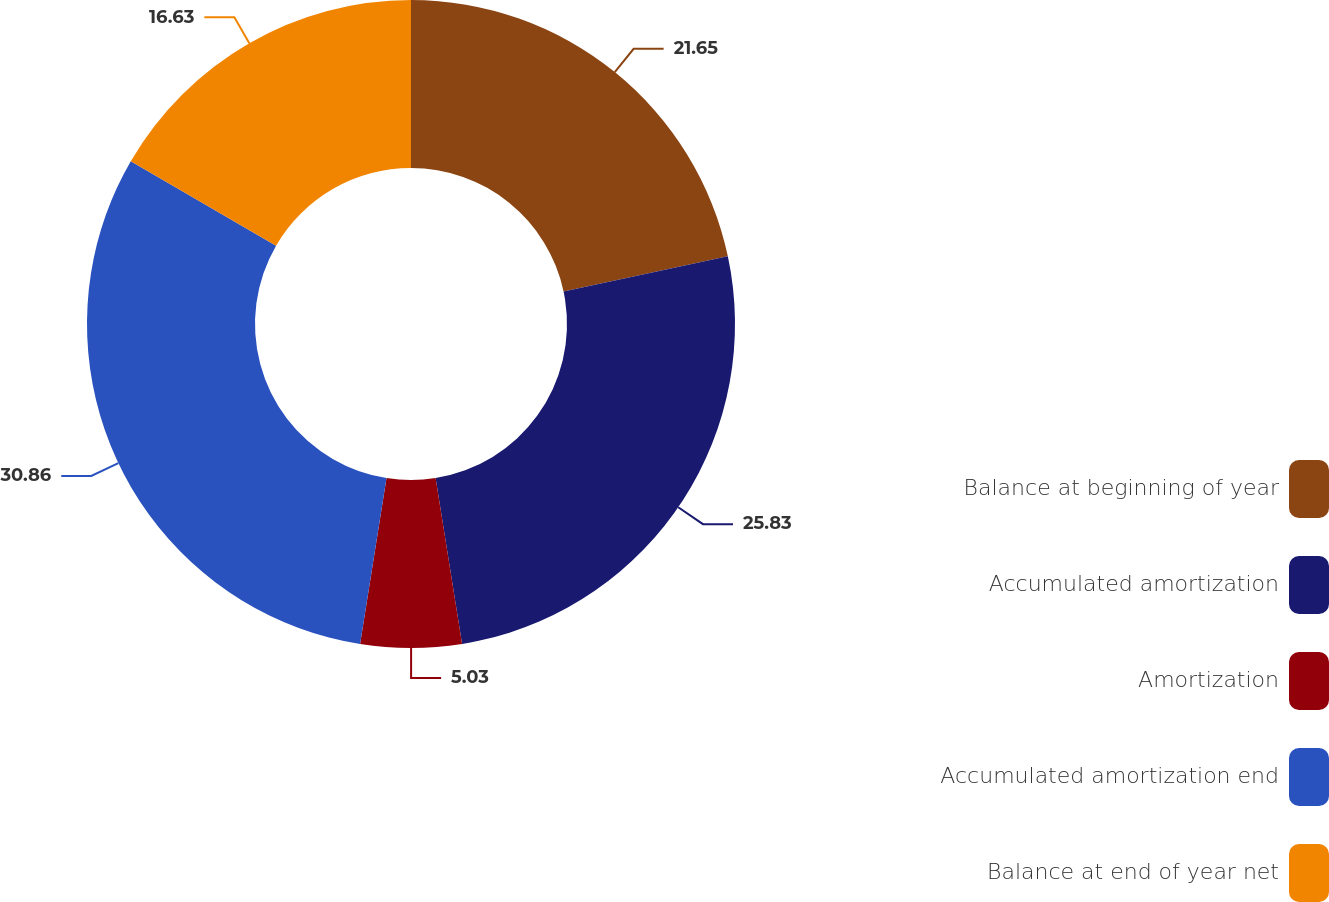<chart> <loc_0><loc_0><loc_500><loc_500><pie_chart><fcel>Balance at beginning of year<fcel>Accumulated amortization<fcel>Amortization<fcel>Accumulated amortization end<fcel>Balance at end of year net<nl><fcel>21.65%<fcel>25.83%<fcel>5.03%<fcel>30.86%<fcel>16.63%<nl></chart> 